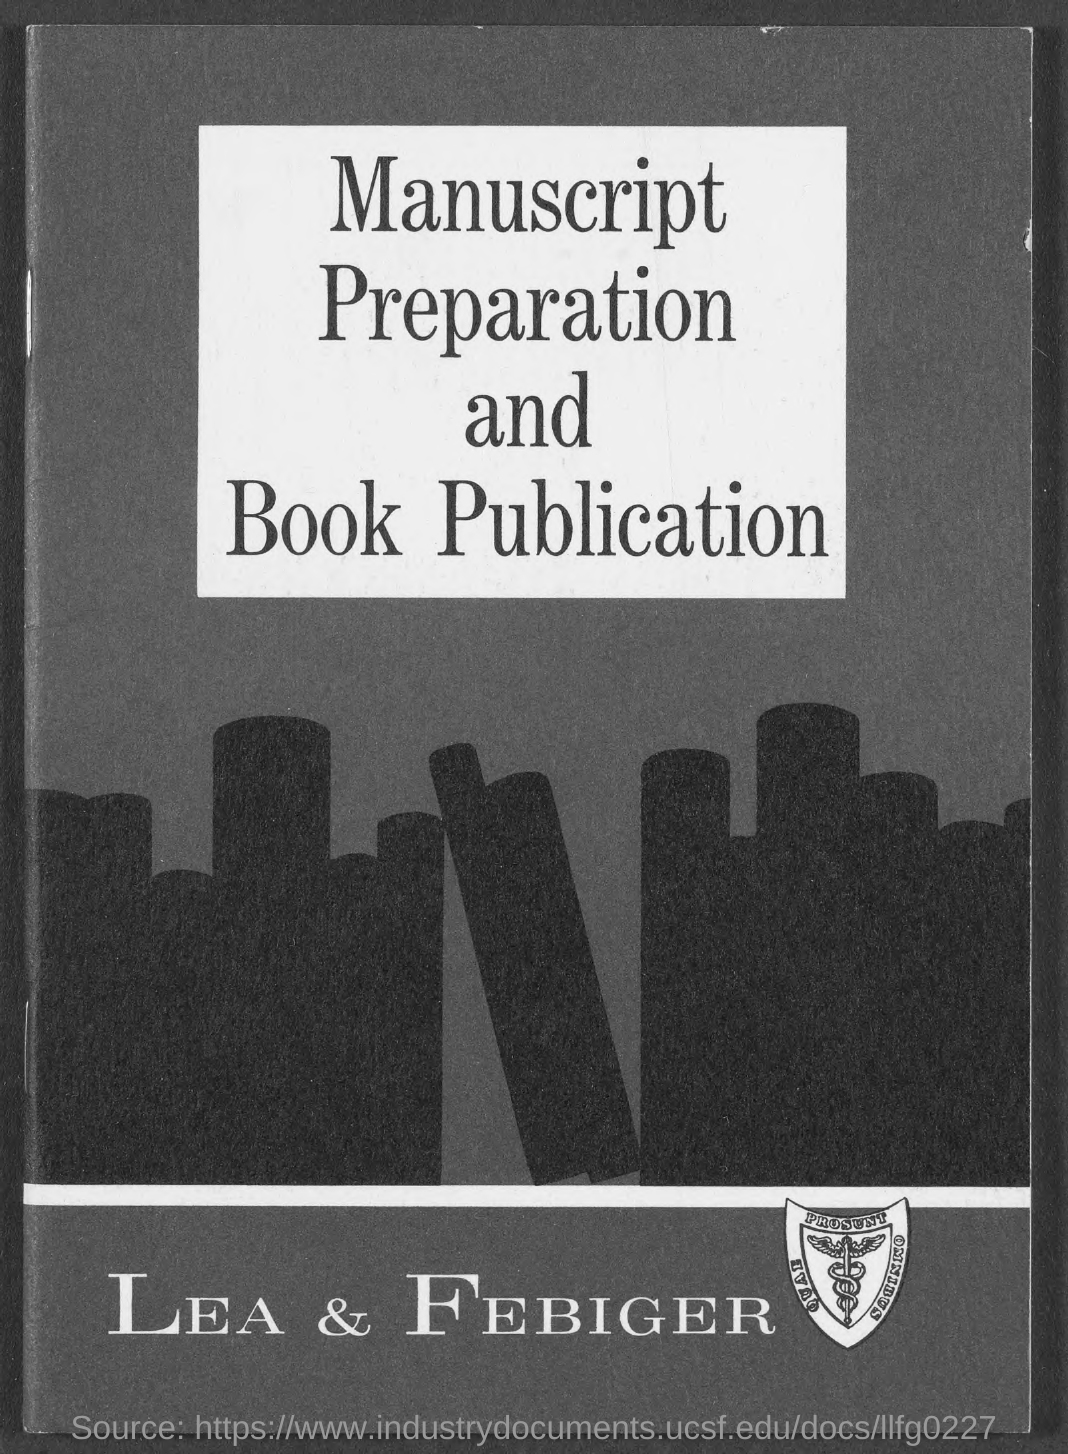Indicate a few pertinent items in this graphic. The book publisher mentioned in the document is LEA & FEBIGER. 